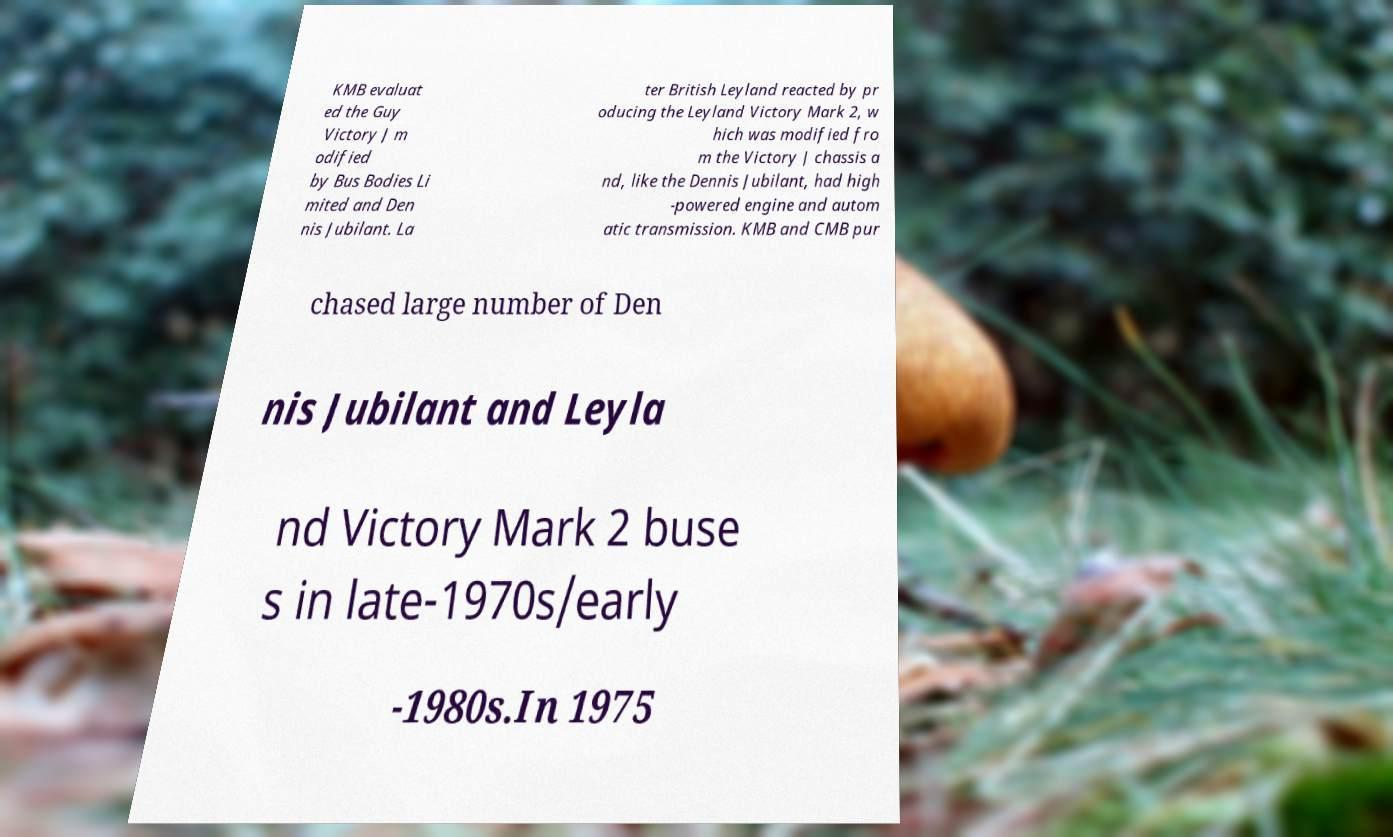Please read and relay the text visible in this image. What does it say? KMB evaluat ed the Guy Victory J m odified by Bus Bodies Li mited and Den nis Jubilant. La ter British Leyland reacted by pr oducing the Leyland Victory Mark 2, w hich was modified fro m the Victory J chassis a nd, like the Dennis Jubilant, had high -powered engine and autom atic transmission. KMB and CMB pur chased large number of Den nis Jubilant and Leyla nd Victory Mark 2 buse s in late-1970s/early -1980s.In 1975 